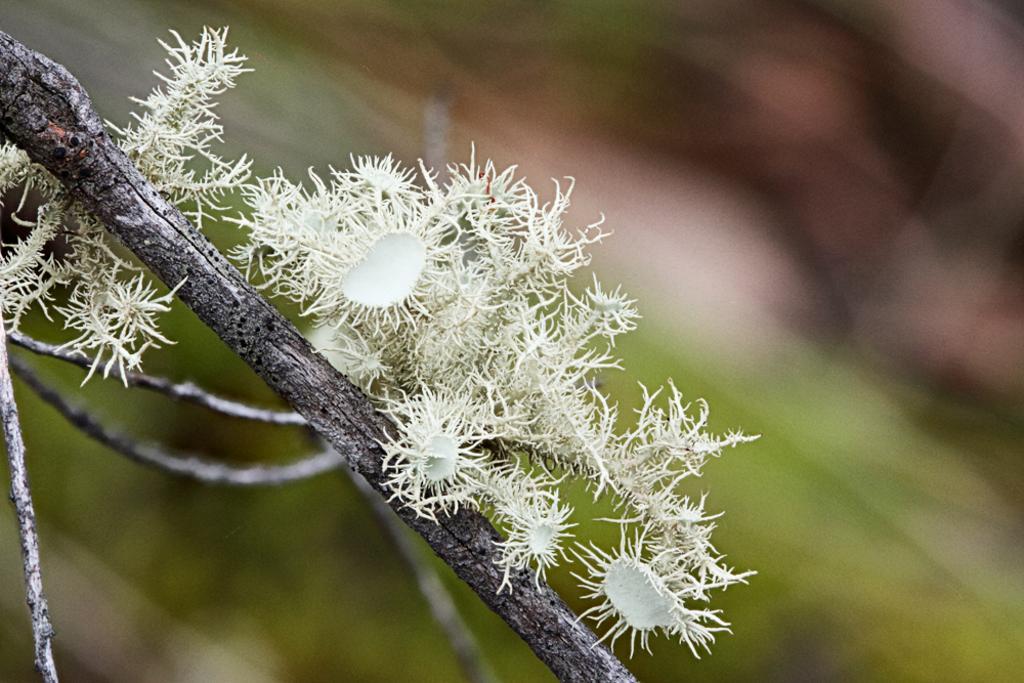Can you describe this image briefly? In this image, we can see some white colored objects on the branch of a tree. We can also see the blurred background. 